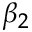<formula> <loc_0><loc_0><loc_500><loc_500>\beta _ { 2 }</formula> 